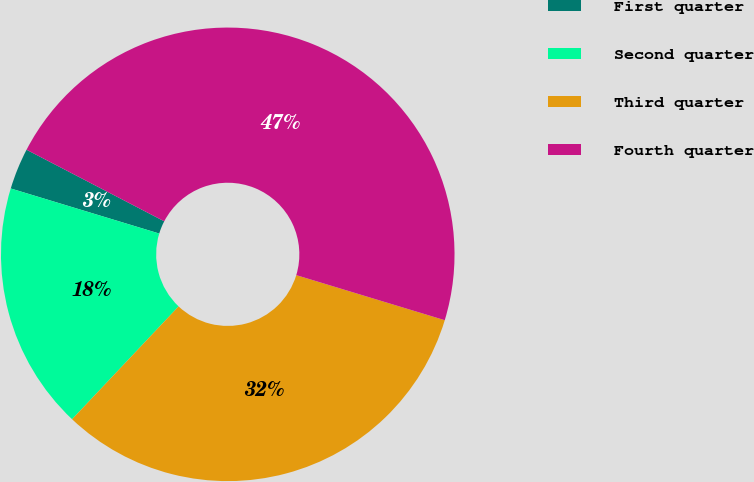<chart> <loc_0><loc_0><loc_500><loc_500><pie_chart><fcel>First quarter<fcel>Second quarter<fcel>Third quarter<fcel>Fourth quarter<nl><fcel>2.94%<fcel>17.65%<fcel>32.35%<fcel>47.06%<nl></chart> 